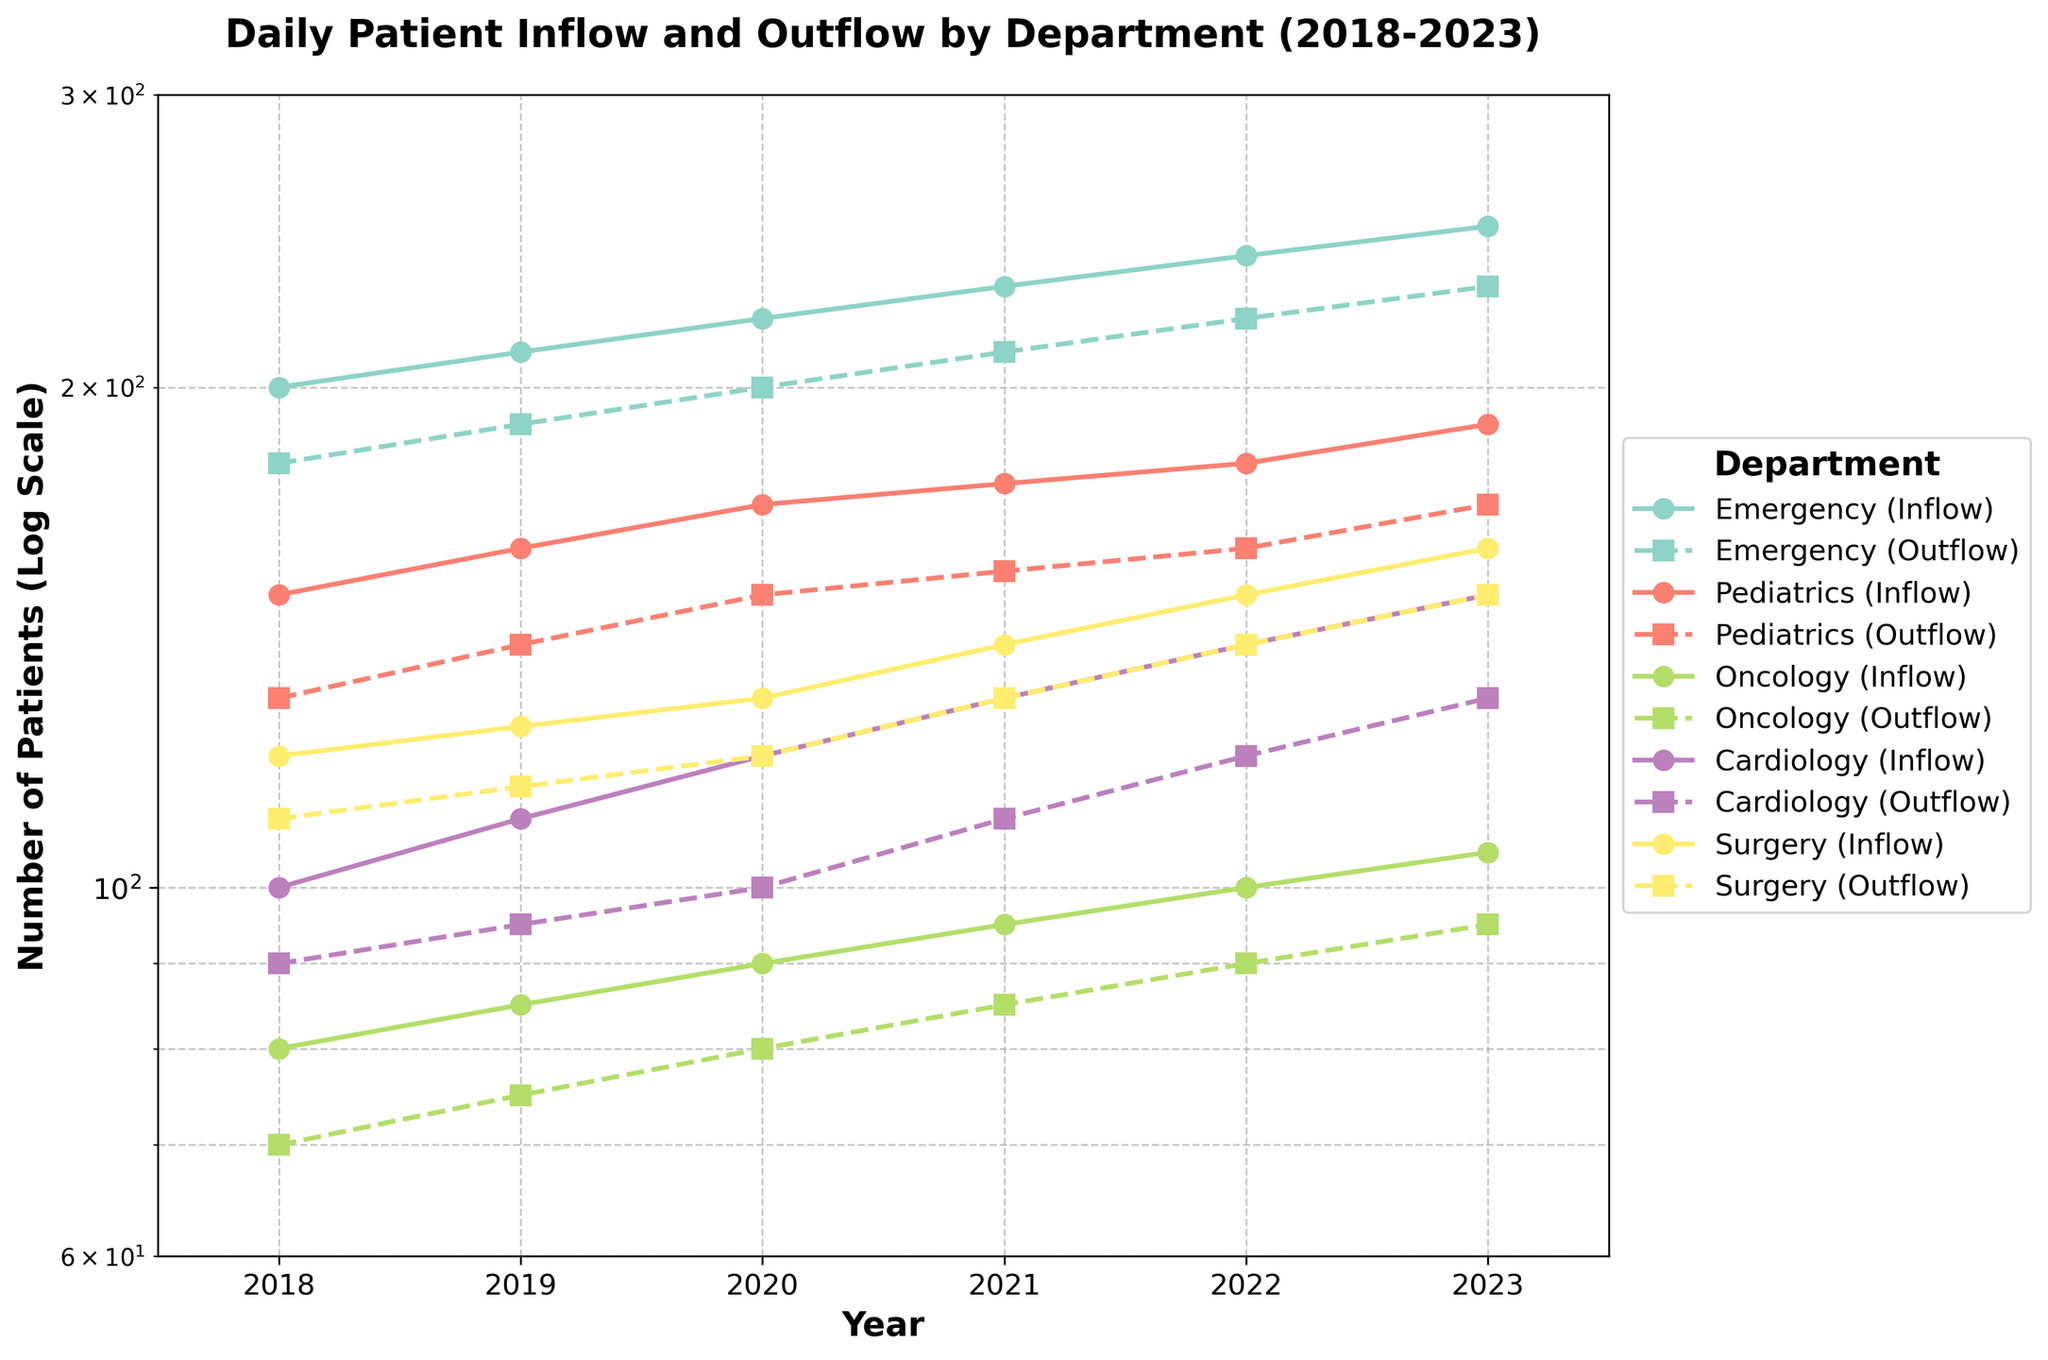What's the title of the figure? The title is usually located at the top of the figure. By reading the text there, we can determine the title.
Answer: Daily Patient Inflow and Outflow by Department (2018-2023) What are the years displayed on the x-axis? The x-axis represents the years. By looking at the labels on the x-axis, we can identify the range of years.
Answer: 2018-2023 Which department shows the highest daily inflow in 2023? We need to look for the highest data point under 'Daily_Inflow' for the year 2023. Checking each department's line and identifying the highest value will give us the answer.
Answer: Emergency Which department had a daily outflow increase from 2018 to 2023? We will trace each department's 'Daily_Outflow' line from 2018 to 2023 and see which have values that increased.
Answer: All departments How does the daily inflow for Pediatrics in 2020 compare to the daily inflow for Cardiology in the same year? By locating the 2020 data points for 'Daily_Inflow' lines of Pediatrics and Cardiology, we can compare their values to see which is higher, lower, or if they are equal.
Answer: Pediatrics had higher inflow (170 vs. 120) What is the average daily inflow for Emergency from 2018 to 2023? Sum up the 'Daily_Inflow' values for Emergency in all the given years (200+210+220+230+240+250) and divide by the number of years (6) to calculate the average.
Answer: 225 Which department shows the least variability in daily outflow from 2018 to 2023? We need to observe the 'Daily_Outflow' lines and identify the department with the flattest or least variable line from 2018 to 2023.
Answer: Oncology What is the daily inflow trend in Oncology from 2018 to 2023? By following the 'Daily_Inflow' line for Oncology from 2018 to 2023, we can describe the trend whether it's increasing, decreasing, or stable.
Answer: Increasing Which department had the closest daily inflow and outflow in 2022? We need to compare the difference between 'Daily_Inflow' and 'Daily_Outflow' for each department in 2022 and find the smallest difference.
Answer: Surgery (difference of 10) Which department shows a consistent increase in both inflow and outflow over the years? By observing both 'Daily_Inflow' and 'Daily_Outflow' lines for each department, we can identify any department with consistently upward trends in both metrics from 2018 to 2023.
Answer: Emergency 